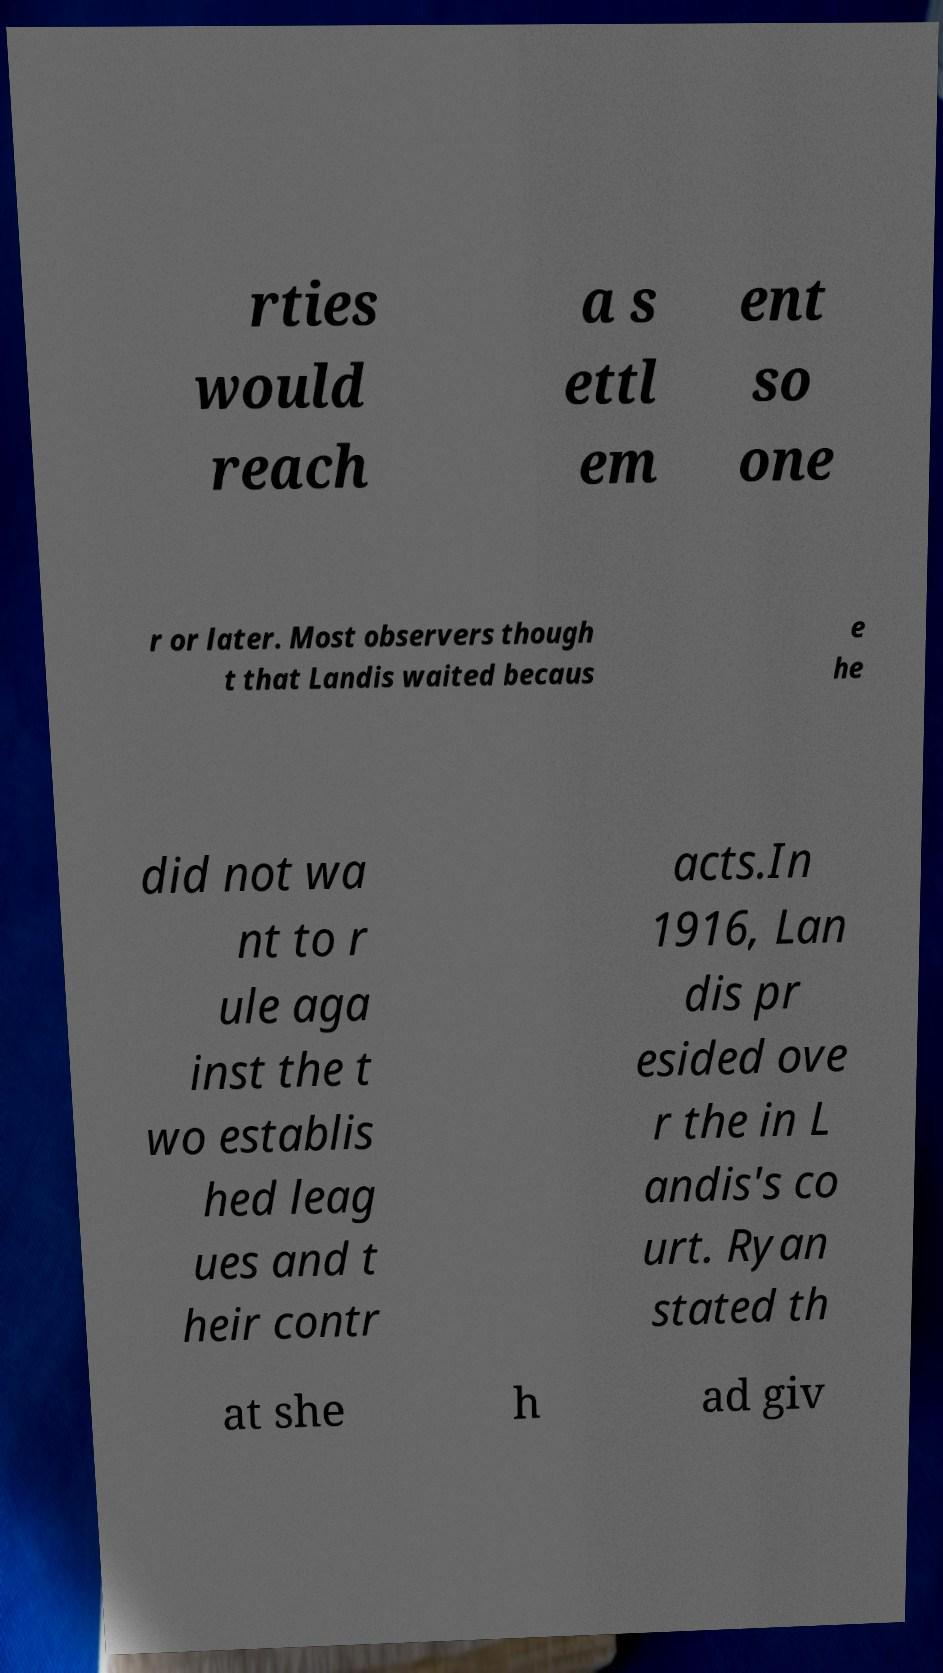Please read and relay the text visible in this image. What does it say? rties would reach a s ettl em ent so one r or later. Most observers though t that Landis waited becaus e he did not wa nt to r ule aga inst the t wo establis hed leag ues and t heir contr acts.In 1916, Lan dis pr esided ove r the in L andis's co urt. Ryan stated th at she h ad giv 